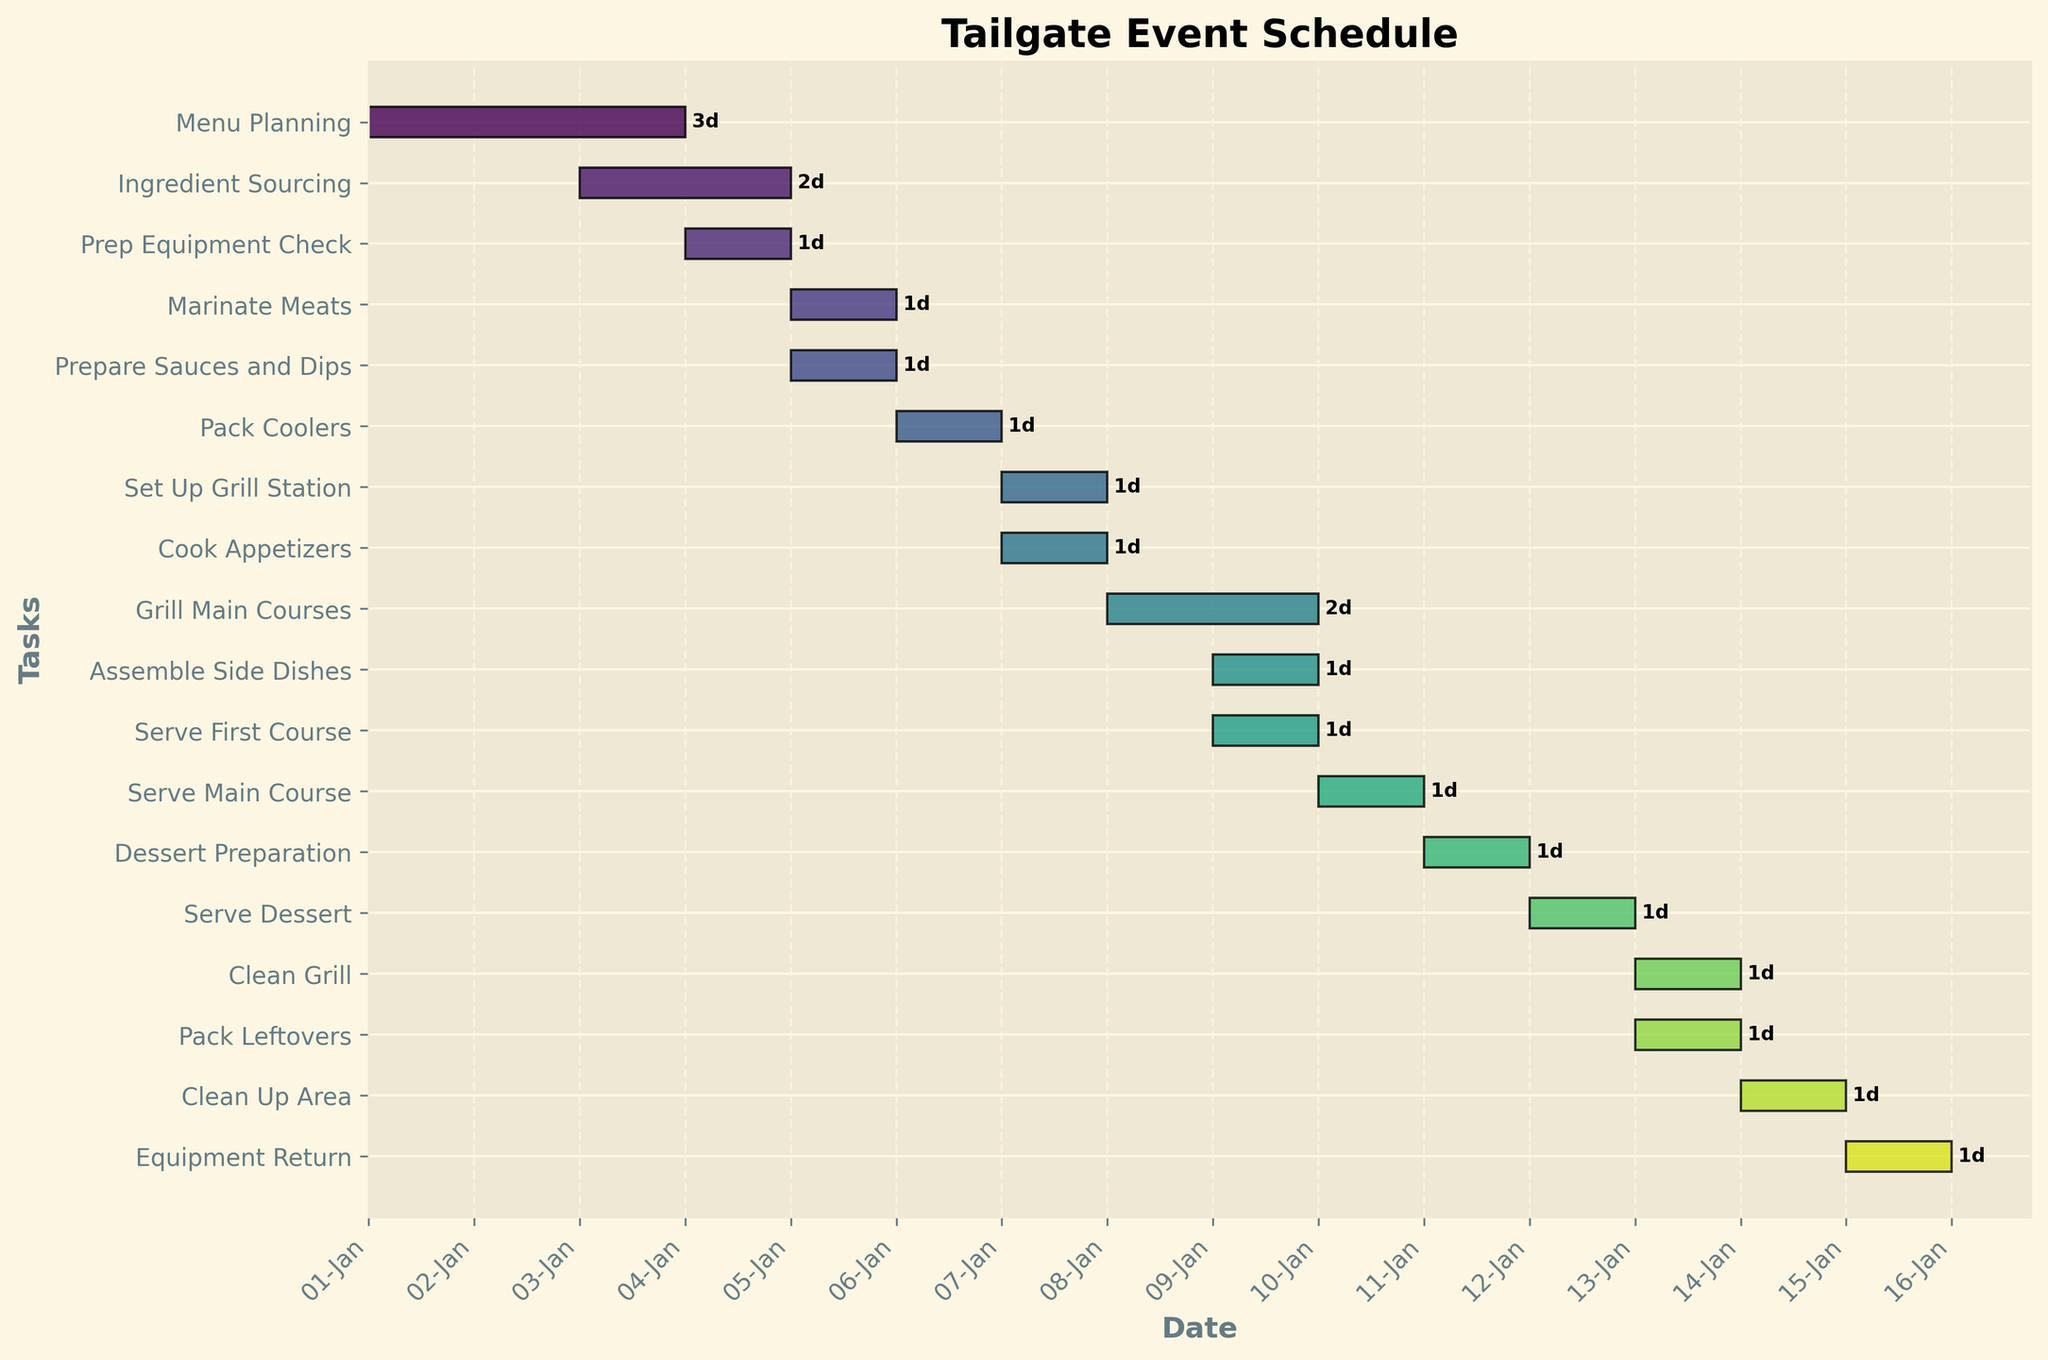How many days does the entire tailgate event last? First, identify the last task, which is "Equipment Return," starting on day 15. The event starts with "Menu Planning" on day 1. Therefore, the duration is from day 1 to day 15.
Answer: 15 days Which tasks occur on the same day as "Cook Appetizers"? "Cook Appetizers" starts on day 7. "Set Up Grill Station" also starts on day 7.
Answer: "Set Up Grill Station" What is the duration of the longest task in the schedule? The longest task is "Grill Main Courses," lasting for 2 days.
Answer: 2 days Which task is scheduled to finish the event? The last task listed is "Equipment Return," which ends on day 15.
Answer: "Equipment Return" How many tasks are scheduled on day 13? The tasks on day 13 are "Clean Grill" and "Pack Leftovers." Therefore, there are 2 tasks scheduled on day 13.
Answer: 2 tasks What is the total duration of tasks related to preparation (e.g., "Menu Planning," "Ingredient Sourcing," etc.)? Preparation tasks include "Menu Planning" (3 days), "Ingredient Sourcing" (2 days), "Prep Equipment Check" (1 day), "Marinate Meats" (1 day), and "Prepare Sauces and Dips" (1 day). The total duration is 3 + 2 + 1 + 1 + 1 = 8 days.
Answer: 8 days Which day involves the highest number of unique tasks? Day 7 involves "Set Up Grill Station" and "Cook Appetizers," totaling 2 tasks. This matches day 13, which has "Clean Grill" and "Pack Leftovers." Both days have the highest number of unique tasks (2 tasks each).
Answer: Day 7 and 13 What tasks are scheduled to occur on the last day? The last day is day 15, which has the task "Equipment Return."
Answer: "Equipment Return" Which task(s) overlap with "Grill Main Courses"? "Grill Main Courses" starts on day 8 and lasts for 2 days. Overlapping task "Assemble Side Dishes" starts on day 9.
Answer: "Assemble Side Dishes" 